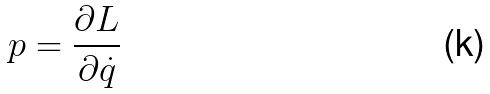Convert formula to latex. <formula><loc_0><loc_0><loc_500><loc_500>p = \frac { \partial L } { \partial \dot { q } }</formula> 